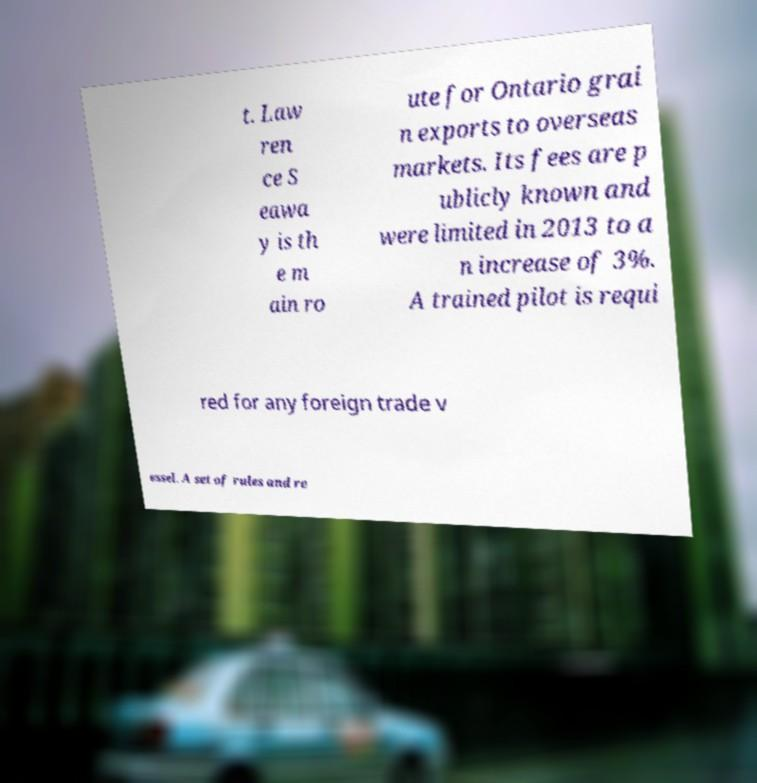Please read and relay the text visible in this image. What does it say? t. Law ren ce S eawa y is th e m ain ro ute for Ontario grai n exports to overseas markets. Its fees are p ublicly known and were limited in 2013 to a n increase of 3%. A trained pilot is requi red for any foreign trade v essel. A set of rules and re 